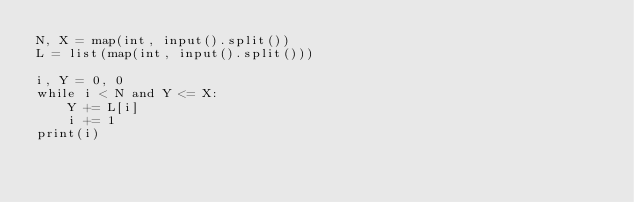<code> <loc_0><loc_0><loc_500><loc_500><_Python_>N, X = map(int, input().split())
L = list(map(int, input().split()))

i, Y = 0, 0
while i < N and Y <= X:
    Y += L[i]
    i += 1
print(i)</code> 